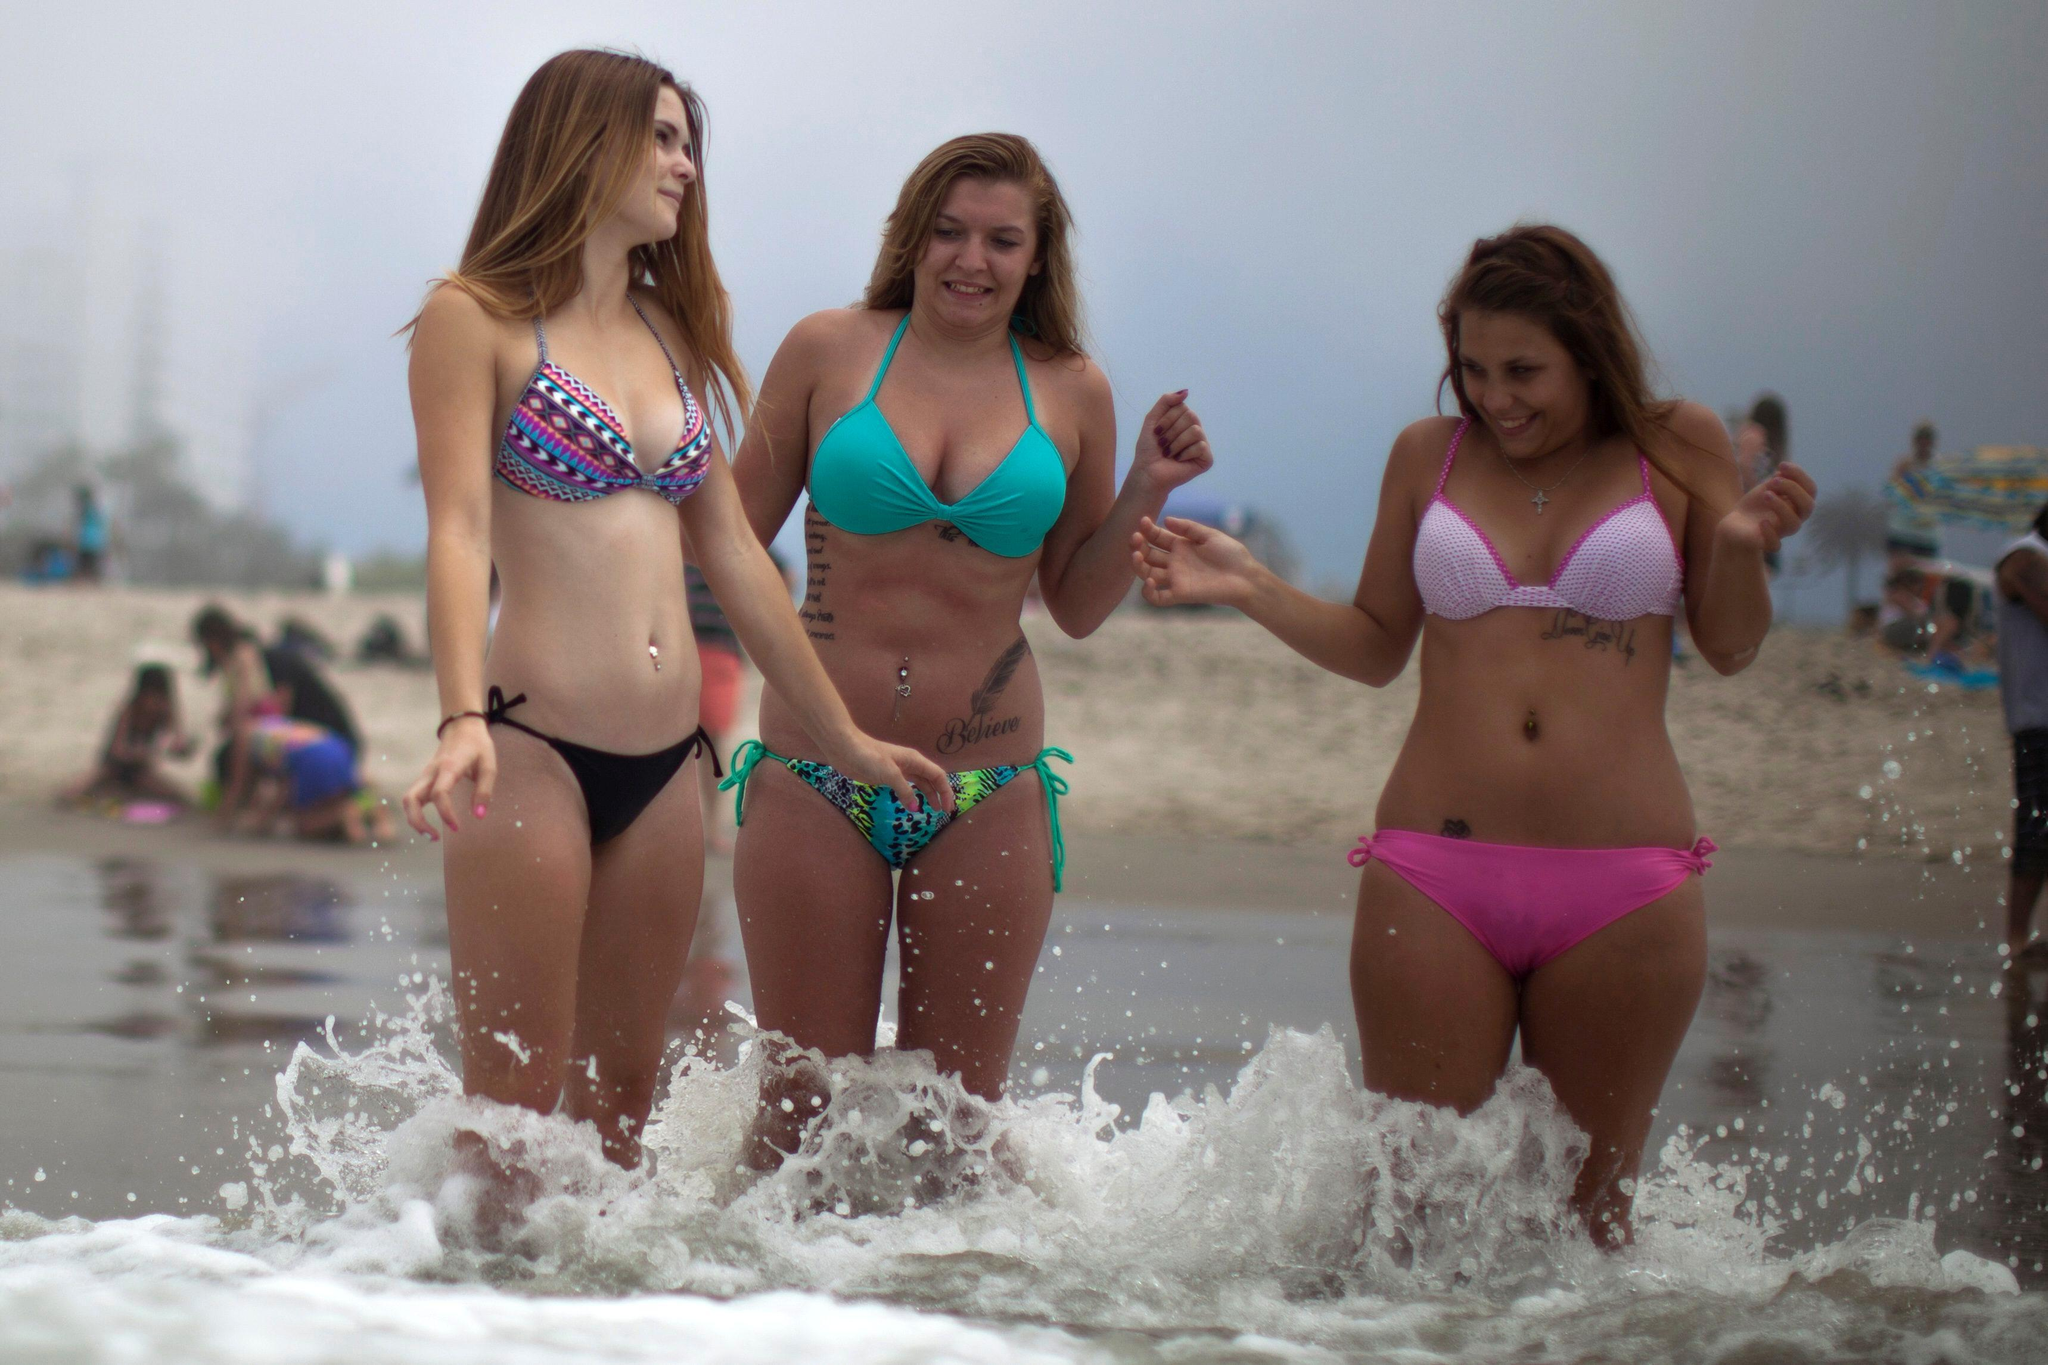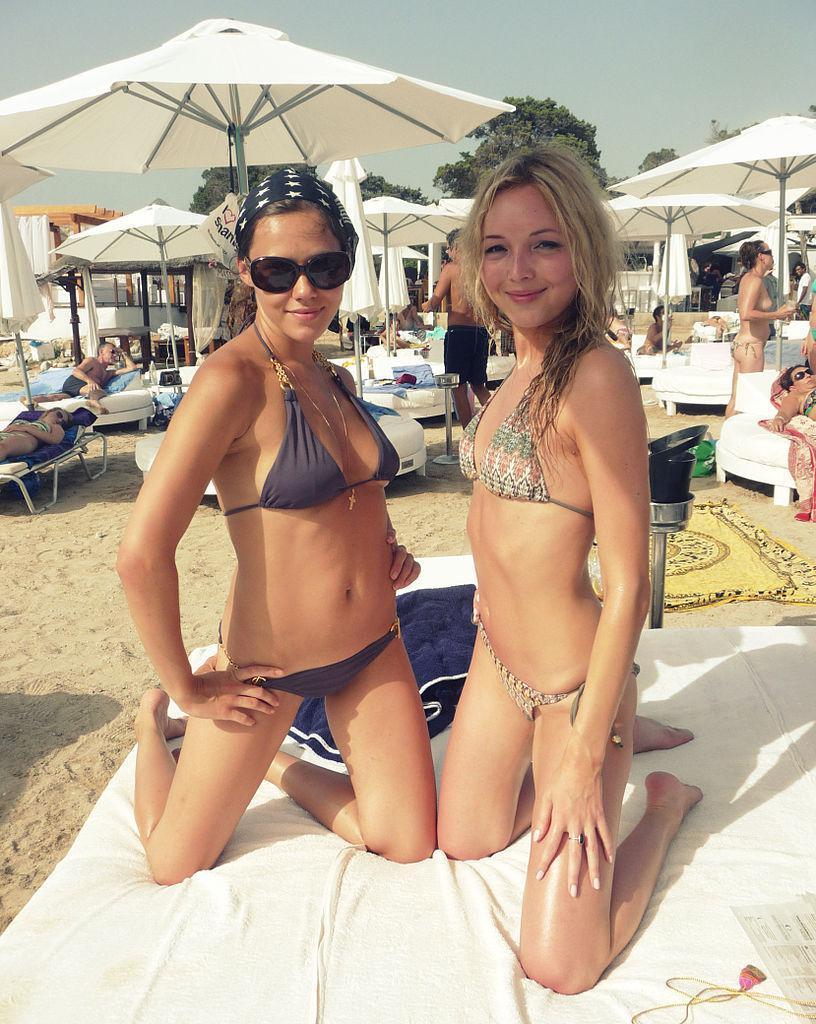The first image is the image on the left, the second image is the image on the right. Evaluate the accuracy of this statement regarding the images: "An image shows three models in different bikini colors.". Is it true? Answer yes or no. Yes. The first image is the image on the left, the second image is the image on the right. Examine the images to the left and right. Is the description "There is at least two females in a bikini in the right image." accurate? Answer yes or no. Yes. 